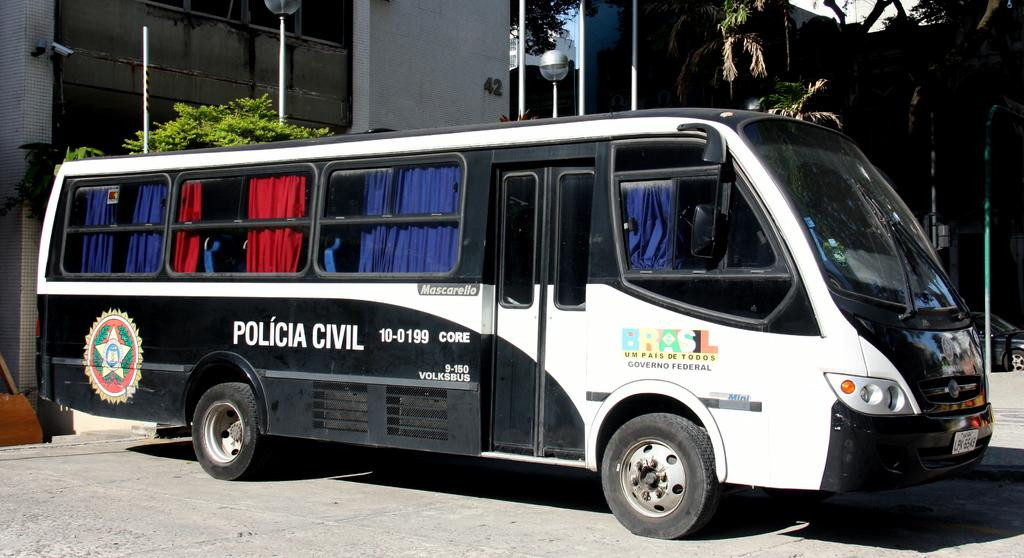What type of vehicle is in the image? There is a bus in the image. What feature can be seen inside the bus? The bus has curtains. Where is the bus located? The bus is on the ground. What other structures are visible in the image? There are poles, trees, and buildings in the image. Can you describe any other vehicles in the image? There is a car visible in the background of the image. Where is the tent set up in the image? There is no tent present in the image. What type of picture is hanging on the wall inside the bus? There is no picture hanging on the wall inside the bus, as the image does not show the interior of the bus. 